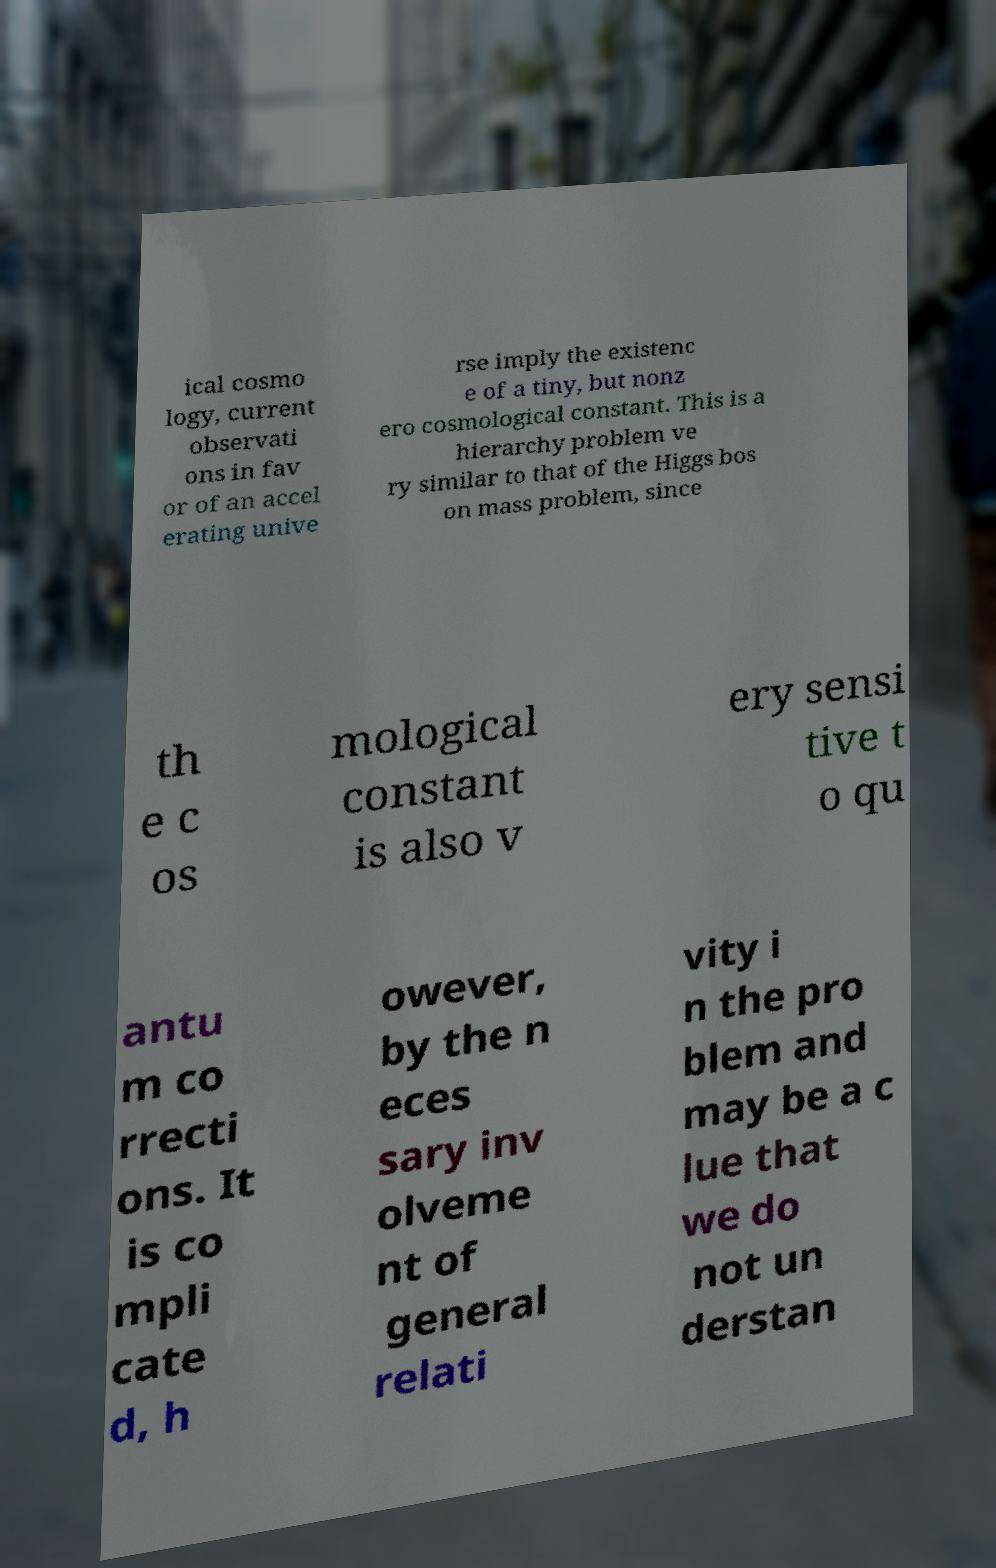Can you read and provide the text displayed in the image?This photo seems to have some interesting text. Can you extract and type it out for me? ical cosmo logy, current observati ons in fav or of an accel erating unive rse imply the existenc e of a tiny, but nonz ero cosmological constant. This is a hierarchy problem ve ry similar to that of the Higgs bos on mass problem, since th e c os mological constant is also v ery sensi tive t o qu antu m co rrecti ons. It is co mpli cate d, h owever, by the n eces sary inv olveme nt of general relati vity i n the pro blem and may be a c lue that we do not un derstan 